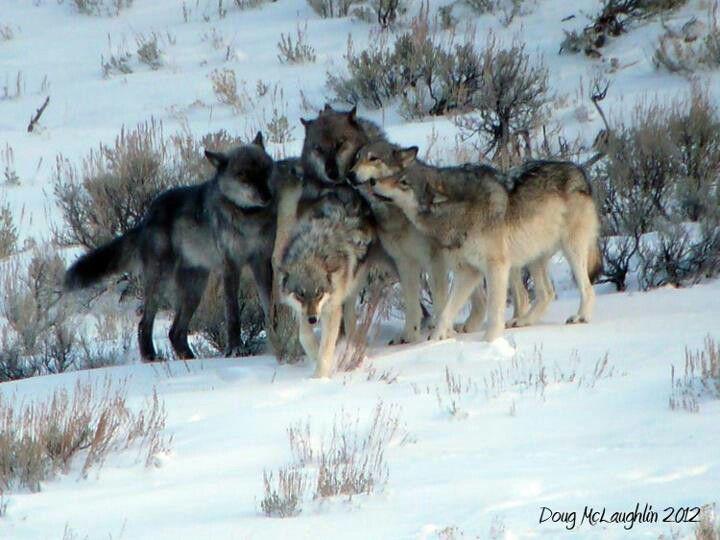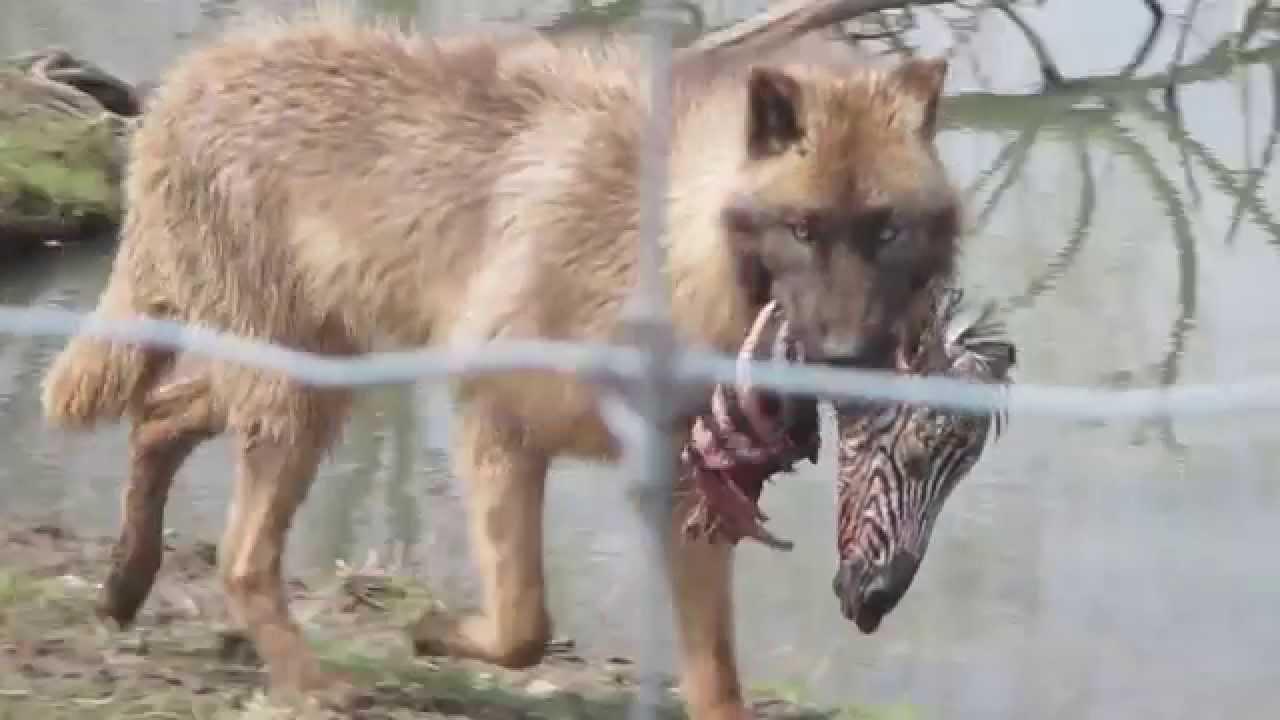The first image is the image on the left, the second image is the image on the right. Assess this claim about the two images: "One image shows a single wolf carrying something in its mouth.". Correct or not? Answer yes or no. Yes. The first image is the image on the left, the second image is the image on the right. Analyze the images presented: Is the assertion "There are exactly three wolves out doors." valid? Answer yes or no. No. 